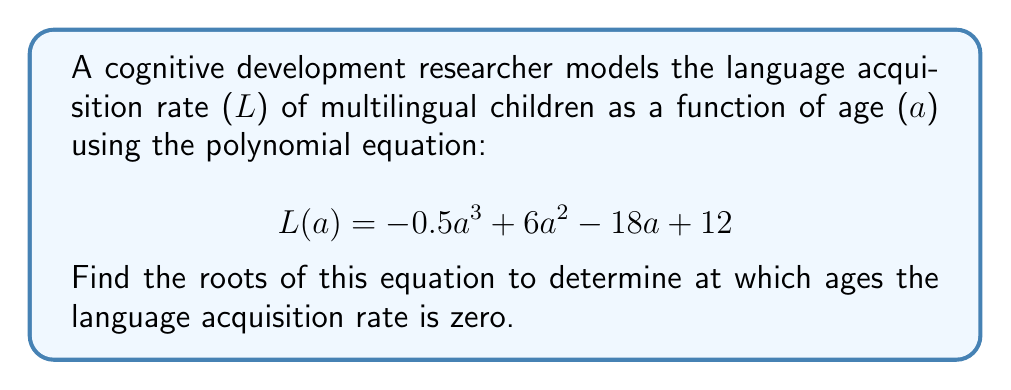Give your solution to this math problem. To find the roots of the polynomial equation, we need to solve:

$$-0.5a^3 + 6a^2 - 18a + 12 = 0$$

Let's approach this step-by-step:

1) First, multiply all terms by -2 to eliminate fractions:

   $$a^3 - 12a^2 + 36a - 24 = 0$$

2) This equation can be factored. Let's try to guess one factor. Notice that 1 is a root of this equation:

   $$1^3 - 12(1)^2 + 36(1) - 24 = 1 - 12 + 36 - 24 = 0$$

3) So $(a-1)$ is a factor. Divide the polynomial by $(a-1)$:

   $$\frac{a^3 - 12a^2 + 36a - 24}{a-1} = a^2 - 11a + 24$$

4) The equation becomes:

   $$(a-1)(a^2 - 11a + 24) = 0$$

5) Now, we can factor the quadratic term $a^2 - 11a + 24$:

   $$(a-1)(a-8)(a-3) = 0$$

6) The roots of this equation are the values of $a$ that make any of these factors zero. So:

   $a = 1$, or $a = 8$, or $a = 3$

These roots represent the ages (in years) at which the language acquisition rate is zero according to this model.
Answer: $a = 1$, $a = 3$, and $a = 8$ 